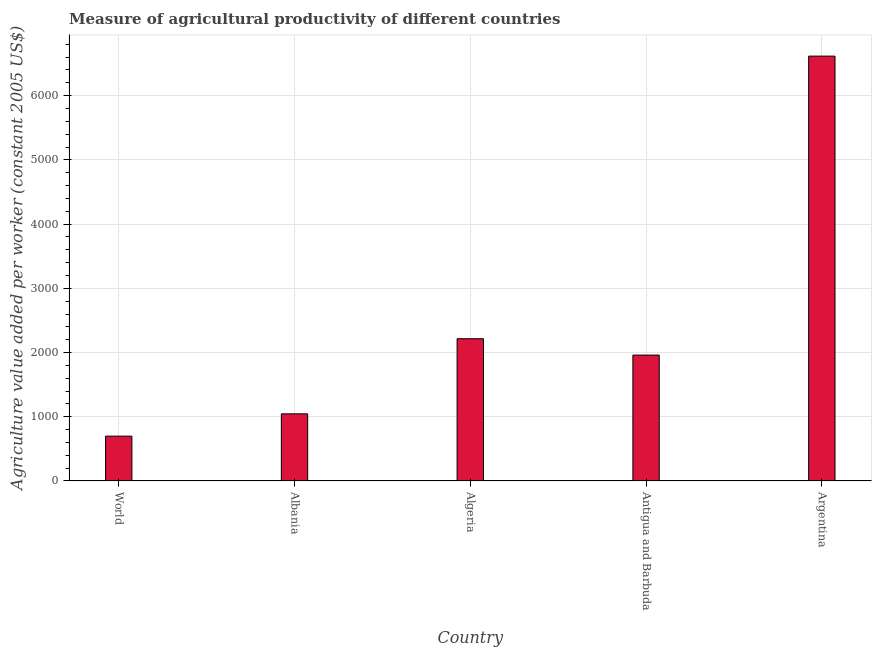Does the graph contain grids?
Provide a short and direct response. Yes. What is the title of the graph?
Offer a very short reply. Measure of agricultural productivity of different countries. What is the label or title of the X-axis?
Make the answer very short. Country. What is the label or title of the Y-axis?
Give a very brief answer. Agriculture value added per worker (constant 2005 US$). What is the agriculture value added per worker in Antigua and Barbuda?
Your answer should be compact. 1960.62. Across all countries, what is the maximum agriculture value added per worker?
Offer a terse response. 6615.78. Across all countries, what is the minimum agriculture value added per worker?
Provide a succinct answer. 698.44. In which country was the agriculture value added per worker minimum?
Ensure brevity in your answer.  World. What is the sum of the agriculture value added per worker?
Your answer should be very brief. 1.25e+04. What is the difference between the agriculture value added per worker in Albania and Antigua and Barbuda?
Keep it short and to the point. -915.03. What is the average agriculture value added per worker per country?
Offer a very short reply. 2507.13. What is the median agriculture value added per worker?
Your answer should be compact. 1960.62. In how many countries, is the agriculture value added per worker greater than 2800 US$?
Give a very brief answer. 1. What is the ratio of the agriculture value added per worker in Antigua and Barbuda to that in World?
Provide a succinct answer. 2.81. Is the difference between the agriculture value added per worker in Albania and Argentina greater than the difference between any two countries?
Offer a terse response. No. What is the difference between the highest and the second highest agriculture value added per worker?
Ensure brevity in your answer.  4400.57. What is the difference between the highest and the lowest agriculture value added per worker?
Your answer should be very brief. 5917.34. How many bars are there?
Provide a short and direct response. 5. How many countries are there in the graph?
Provide a succinct answer. 5. What is the Agriculture value added per worker (constant 2005 US$) of World?
Ensure brevity in your answer.  698.44. What is the Agriculture value added per worker (constant 2005 US$) of Albania?
Make the answer very short. 1045.59. What is the Agriculture value added per worker (constant 2005 US$) of Algeria?
Ensure brevity in your answer.  2215.22. What is the Agriculture value added per worker (constant 2005 US$) in Antigua and Barbuda?
Give a very brief answer. 1960.62. What is the Agriculture value added per worker (constant 2005 US$) of Argentina?
Provide a succinct answer. 6615.78. What is the difference between the Agriculture value added per worker (constant 2005 US$) in World and Albania?
Offer a terse response. -347.15. What is the difference between the Agriculture value added per worker (constant 2005 US$) in World and Algeria?
Offer a terse response. -1516.78. What is the difference between the Agriculture value added per worker (constant 2005 US$) in World and Antigua and Barbuda?
Provide a short and direct response. -1262.18. What is the difference between the Agriculture value added per worker (constant 2005 US$) in World and Argentina?
Your answer should be compact. -5917.34. What is the difference between the Agriculture value added per worker (constant 2005 US$) in Albania and Algeria?
Your answer should be compact. -1169.63. What is the difference between the Agriculture value added per worker (constant 2005 US$) in Albania and Antigua and Barbuda?
Your answer should be very brief. -915.03. What is the difference between the Agriculture value added per worker (constant 2005 US$) in Albania and Argentina?
Provide a succinct answer. -5570.2. What is the difference between the Agriculture value added per worker (constant 2005 US$) in Algeria and Antigua and Barbuda?
Provide a short and direct response. 254.6. What is the difference between the Agriculture value added per worker (constant 2005 US$) in Algeria and Argentina?
Your response must be concise. -4400.57. What is the difference between the Agriculture value added per worker (constant 2005 US$) in Antigua and Barbuda and Argentina?
Your answer should be compact. -4655.16. What is the ratio of the Agriculture value added per worker (constant 2005 US$) in World to that in Albania?
Provide a succinct answer. 0.67. What is the ratio of the Agriculture value added per worker (constant 2005 US$) in World to that in Algeria?
Provide a succinct answer. 0.32. What is the ratio of the Agriculture value added per worker (constant 2005 US$) in World to that in Antigua and Barbuda?
Provide a short and direct response. 0.36. What is the ratio of the Agriculture value added per worker (constant 2005 US$) in World to that in Argentina?
Give a very brief answer. 0.11. What is the ratio of the Agriculture value added per worker (constant 2005 US$) in Albania to that in Algeria?
Provide a short and direct response. 0.47. What is the ratio of the Agriculture value added per worker (constant 2005 US$) in Albania to that in Antigua and Barbuda?
Offer a terse response. 0.53. What is the ratio of the Agriculture value added per worker (constant 2005 US$) in Albania to that in Argentina?
Your response must be concise. 0.16. What is the ratio of the Agriculture value added per worker (constant 2005 US$) in Algeria to that in Antigua and Barbuda?
Offer a very short reply. 1.13. What is the ratio of the Agriculture value added per worker (constant 2005 US$) in Algeria to that in Argentina?
Provide a short and direct response. 0.34. What is the ratio of the Agriculture value added per worker (constant 2005 US$) in Antigua and Barbuda to that in Argentina?
Your response must be concise. 0.3. 